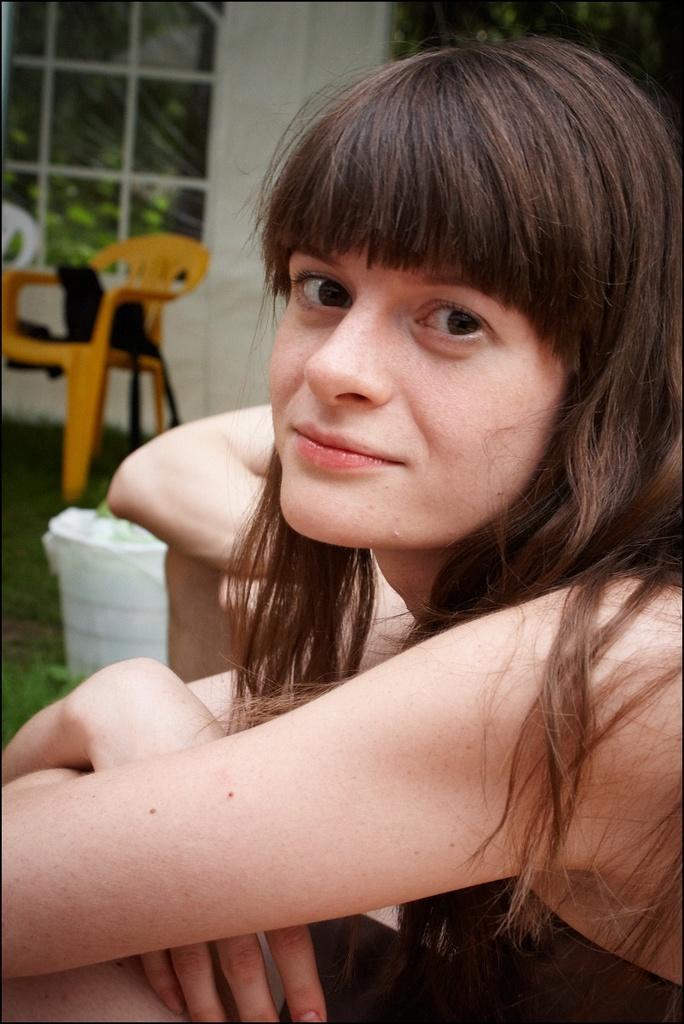In one or two sentences, can you explain what this image depicts? In this image I can see a woman and I can see she is wearing black dress. In background I can see one more person, few chairs, few clothes and I can see this image is little bit blurry from background. 